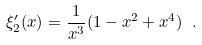<formula> <loc_0><loc_0><loc_500><loc_500>\xi ^ { \prime } _ { 2 } ( x ) = \frac { 1 } { x ^ { 3 } } ( 1 - x ^ { 2 } + x ^ { 4 } ) \ .</formula> 